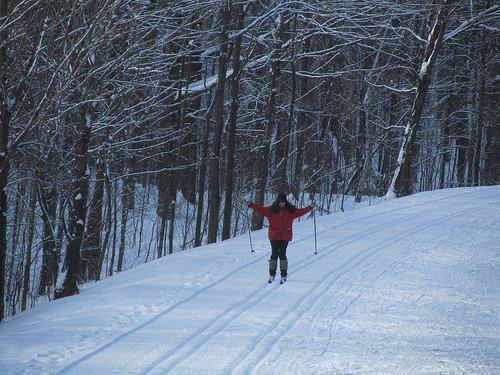How many people are shown here?
Give a very brief answer. 1. How many skis poles does the lady have?
Give a very brief answer. 2. 